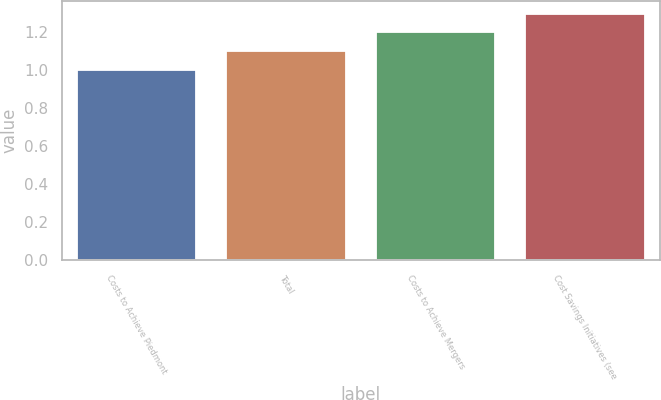Convert chart. <chart><loc_0><loc_0><loc_500><loc_500><bar_chart><fcel>Costs to Achieve Piedmont<fcel>Total<fcel>Costs to Achieve Mergers<fcel>Cost Savings Initiatives (see<nl><fcel>1<fcel>1.1<fcel>1.2<fcel>1.3<nl></chart> 